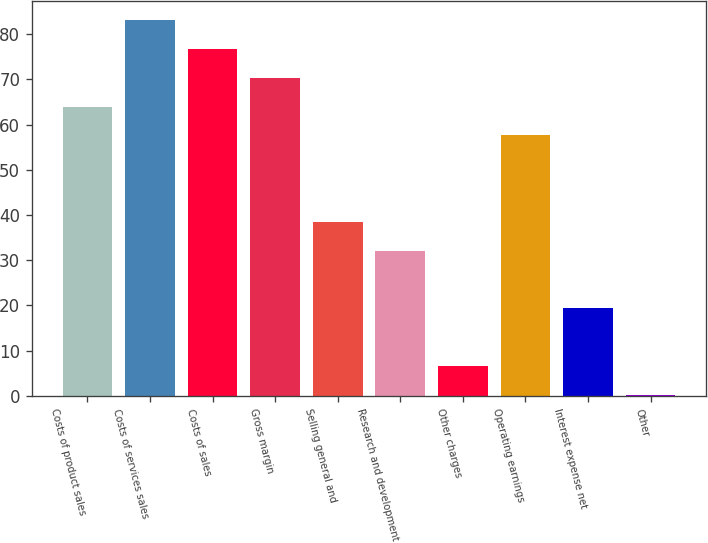Convert chart to OTSL. <chart><loc_0><loc_0><loc_500><loc_500><bar_chart><fcel>Costs of product sales<fcel>Costs of services sales<fcel>Costs of sales<fcel>Gross margin<fcel>Selling general and<fcel>Research and development<fcel>Other charges<fcel>Operating earnings<fcel>Interest expense net<fcel>Other<nl><fcel>64<fcel>83.14<fcel>76.76<fcel>70.38<fcel>38.48<fcel>32.1<fcel>6.58<fcel>57.62<fcel>19.34<fcel>0.2<nl></chart> 